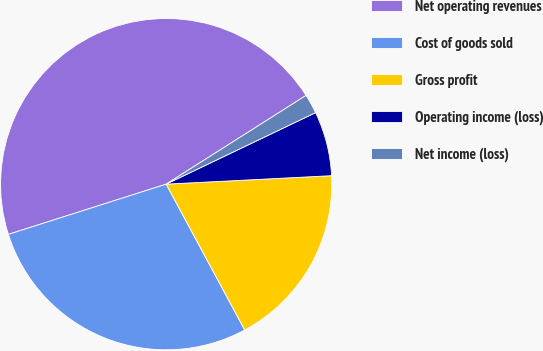Convert chart. <chart><loc_0><loc_0><loc_500><loc_500><pie_chart><fcel>Net operating revenues<fcel>Cost of goods sold<fcel>Gross profit<fcel>Operating income (loss)<fcel>Net income (loss)<nl><fcel>45.91%<fcel>27.96%<fcel>17.95%<fcel>6.29%<fcel>1.89%<nl></chart> 